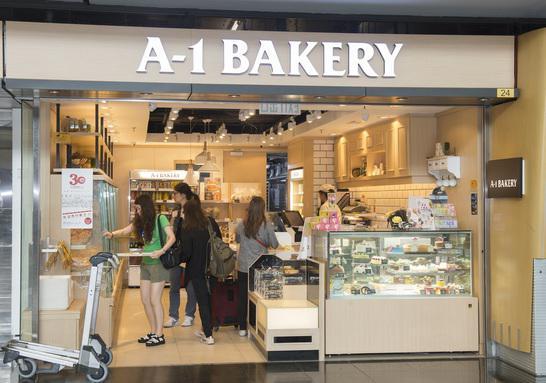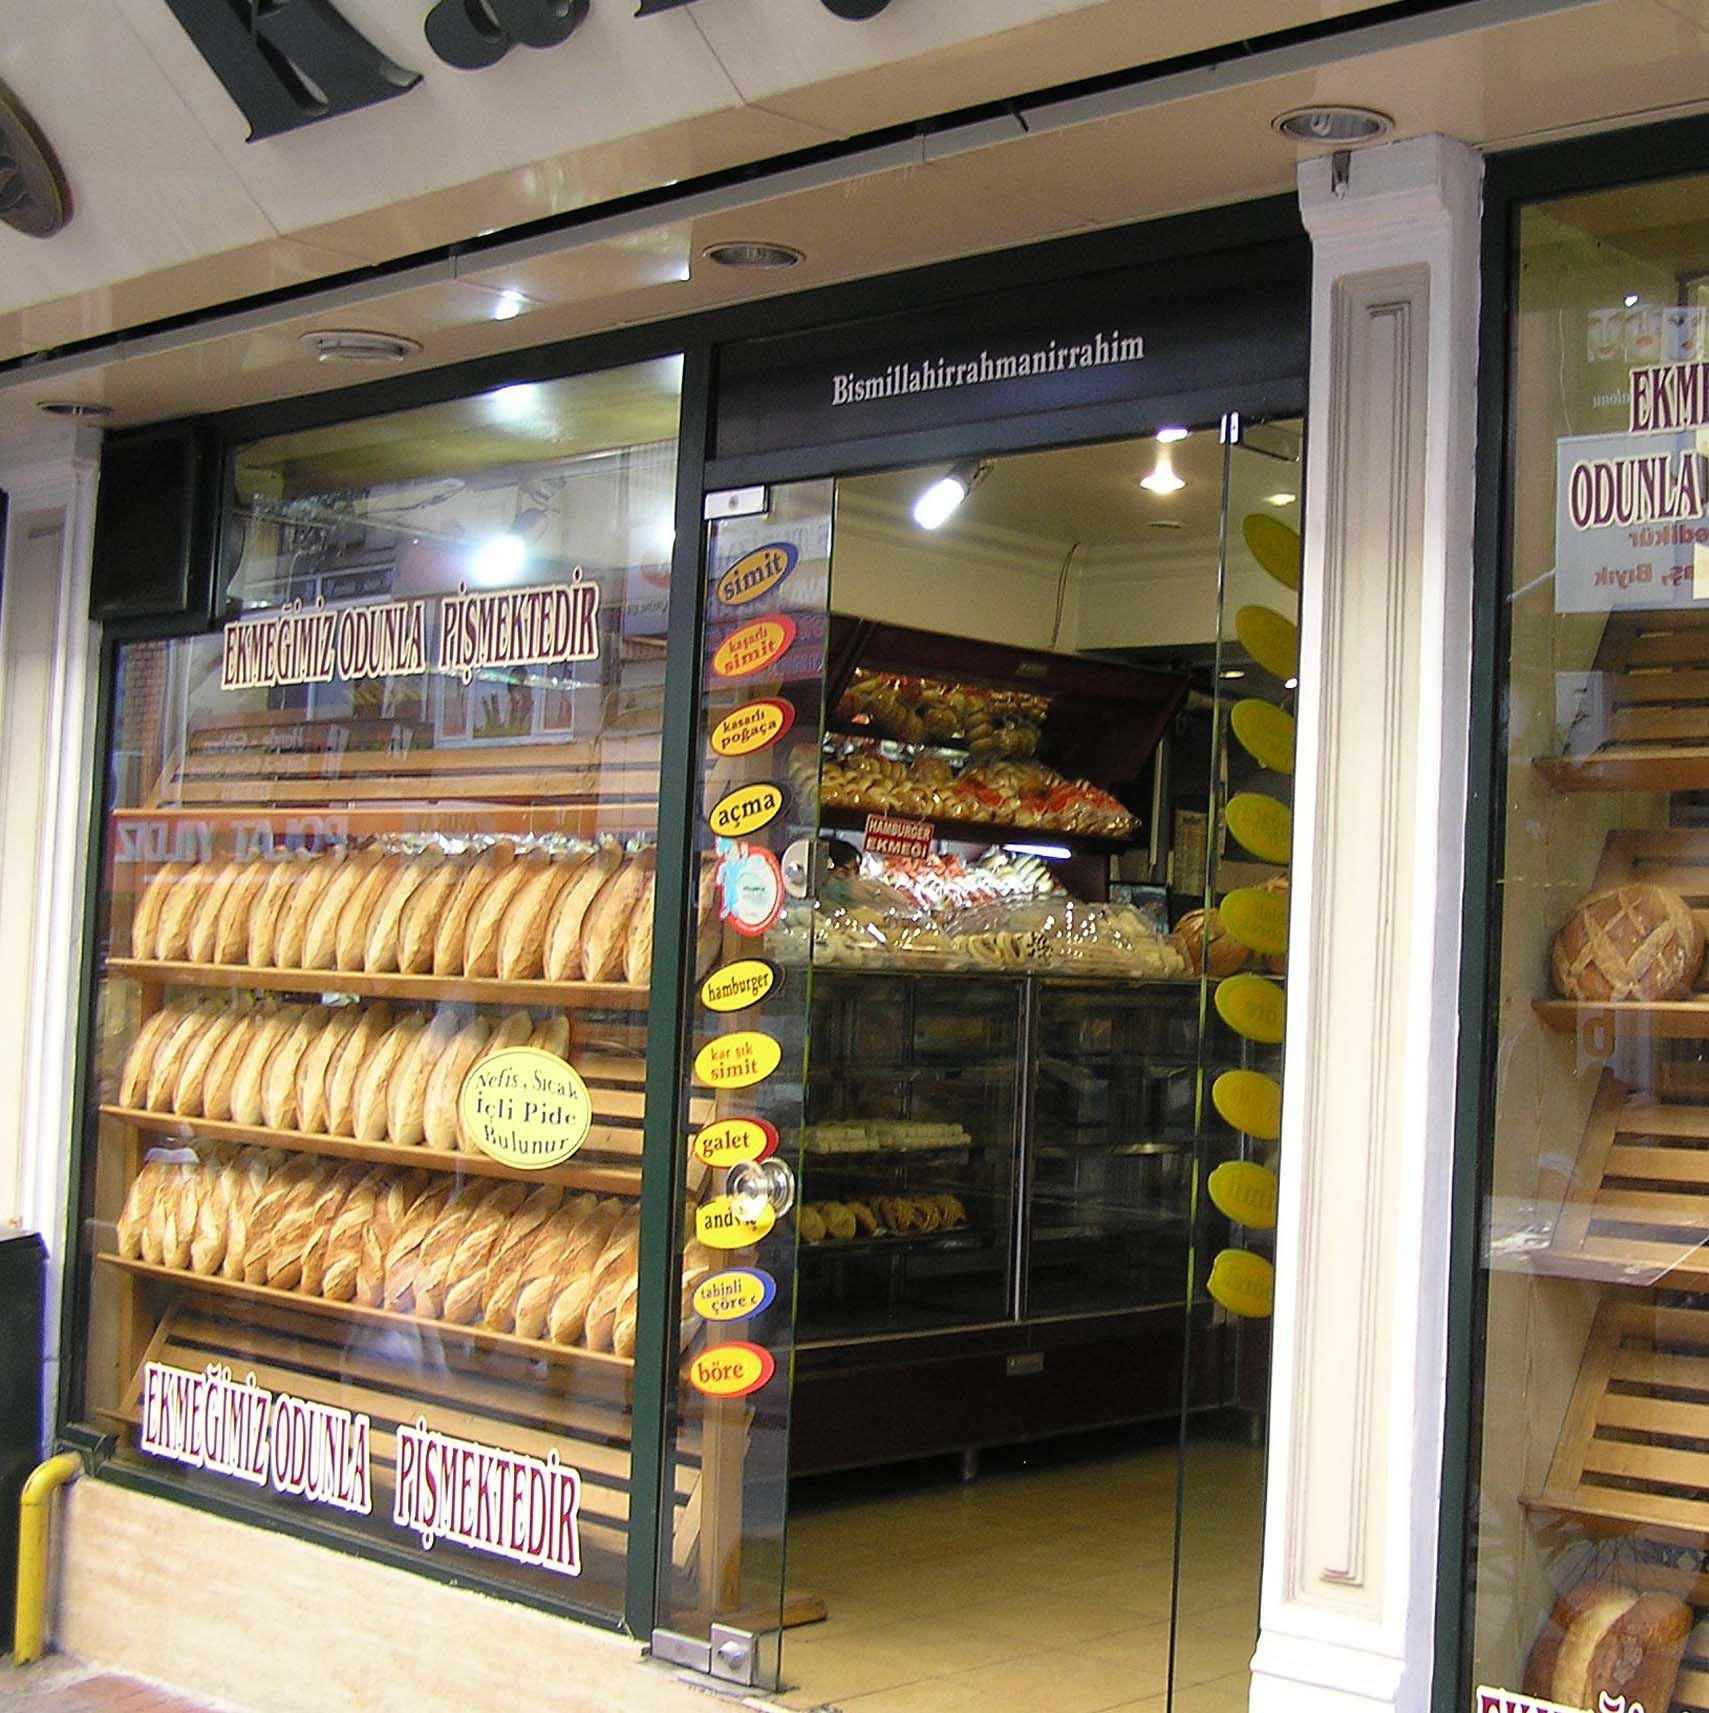The first image is the image on the left, the second image is the image on the right. Considering the images on both sides, is "At least one female with back to the camera is at a service counter in one image." valid? Answer yes or no. Yes. The first image is the image on the left, the second image is the image on the right. Assess this claim about the two images: "People stand at the counter waiting for service in the image on the left.". Correct or not? Answer yes or no. Yes. 